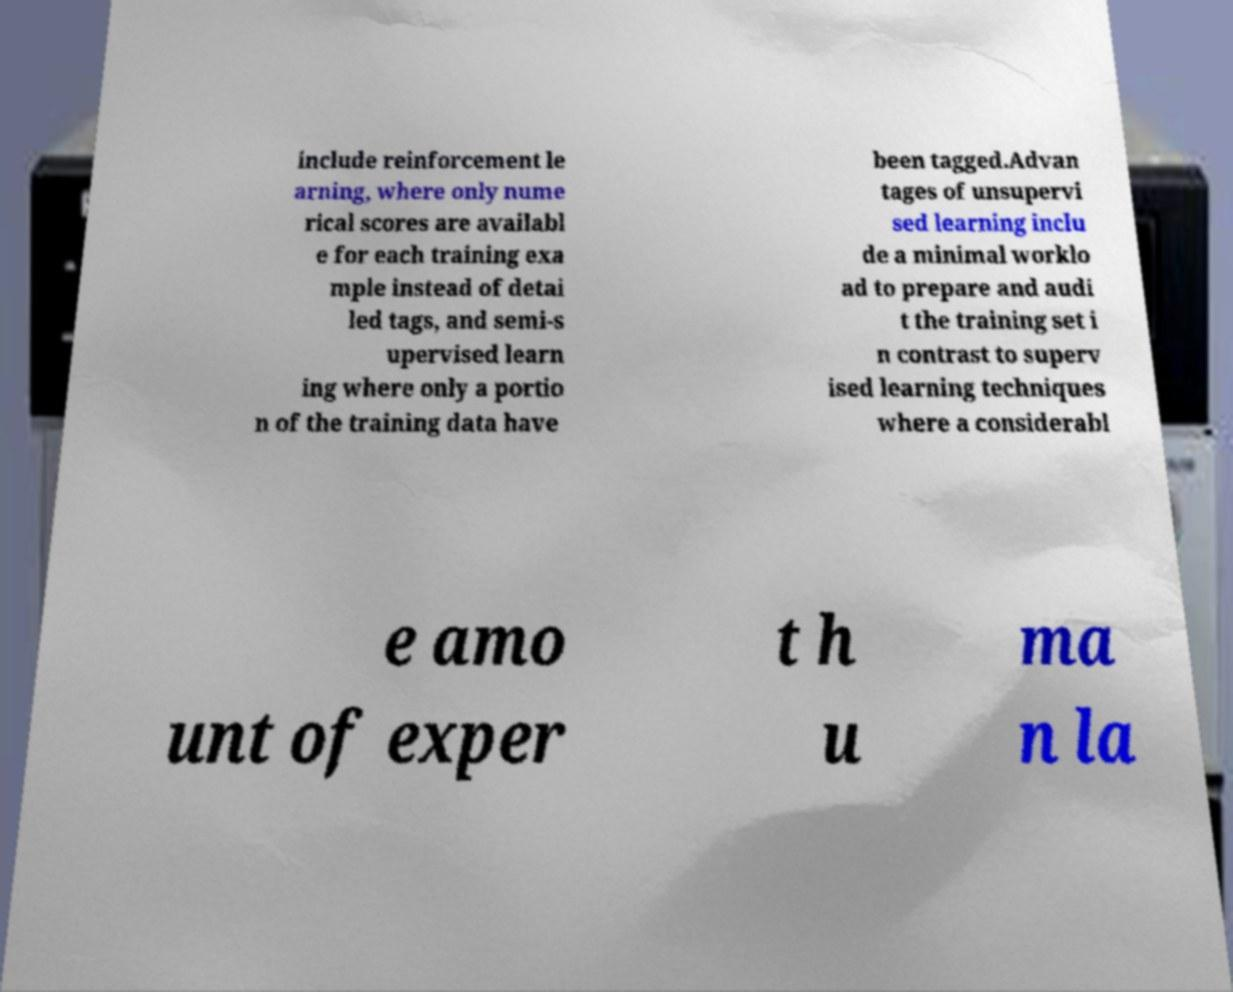Could you assist in decoding the text presented in this image and type it out clearly? include reinforcement le arning, where only nume rical scores are availabl e for each training exa mple instead of detai led tags, and semi-s upervised learn ing where only a portio n of the training data have been tagged.Advan tages of unsupervi sed learning inclu de a minimal worklo ad to prepare and audi t the training set i n contrast to superv ised learning techniques where a considerabl e amo unt of exper t h u ma n la 